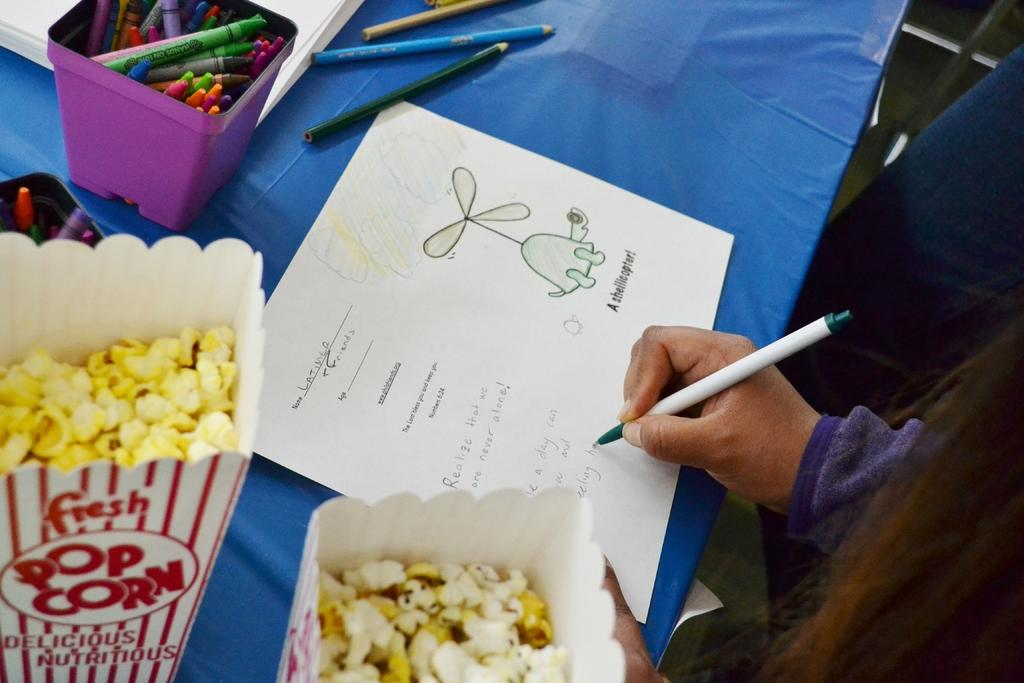Where is the person located in the image? The person is standing in the bottom right side of the image. What is the person holding in the image? The person is holding a pen. What is in the middle of the image? There is a table in the middle of the image. What is on the table? There is a paper on the table, as well as pens and popcorn. What type of rhythm can be heard coming from the popcorn in the image? There is no sound or rhythm associated with the popcorn in the image; it is simply a food item on the table. 